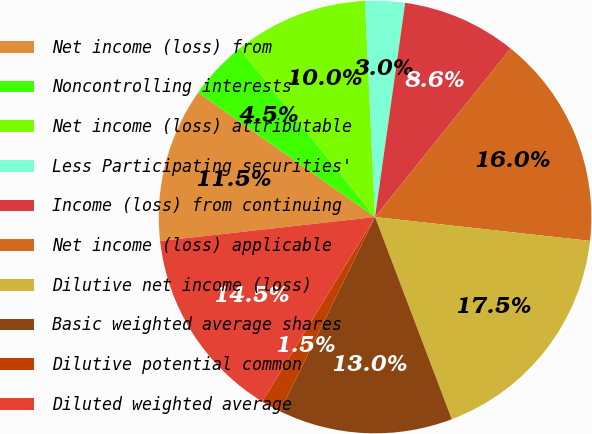Convert chart to OTSL. <chart><loc_0><loc_0><loc_500><loc_500><pie_chart><fcel>Net income (loss) from<fcel>Noncontrolling interests'<fcel>Net income (loss) attributable<fcel>Less Participating securities'<fcel>Income (loss) from continuing<fcel>Net income (loss) applicable<fcel>Dilutive net income (loss)<fcel>Basic weighted average shares<fcel>Dilutive potential common<fcel>Diluted weighted average<nl><fcel>11.53%<fcel>4.46%<fcel>10.04%<fcel>2.97%<fcel>8.56%<fcel>15.98%<fcel>17.47%<fcel>13.01%<fcel>1.49%<fcel>14.5%<nl></chart> 